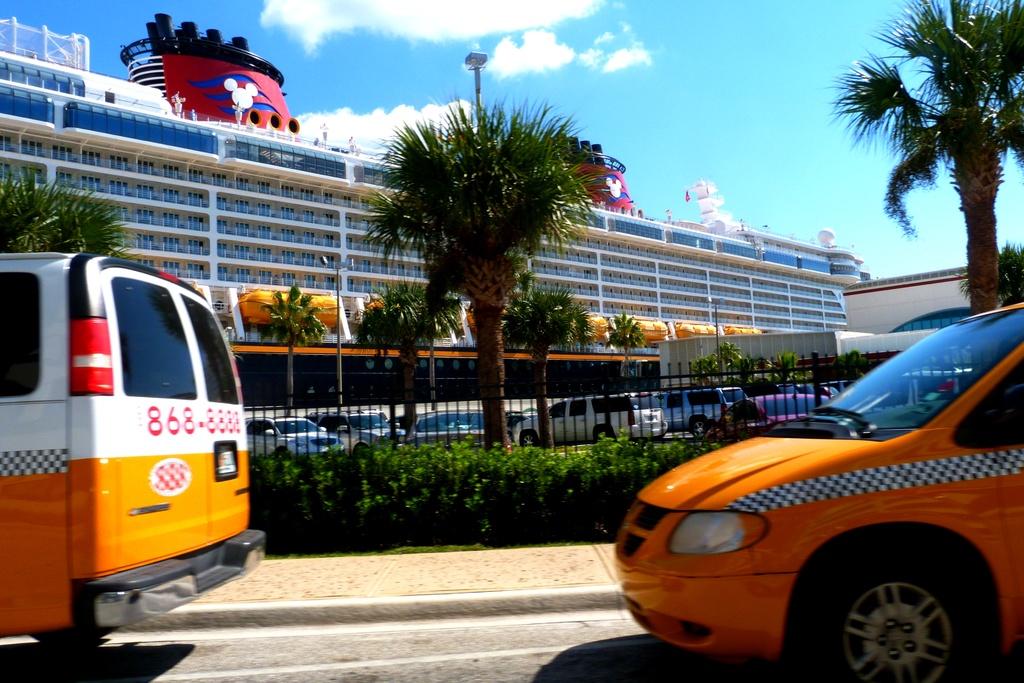What is the first number of the phone number?
Give a very brief answer. 8. 